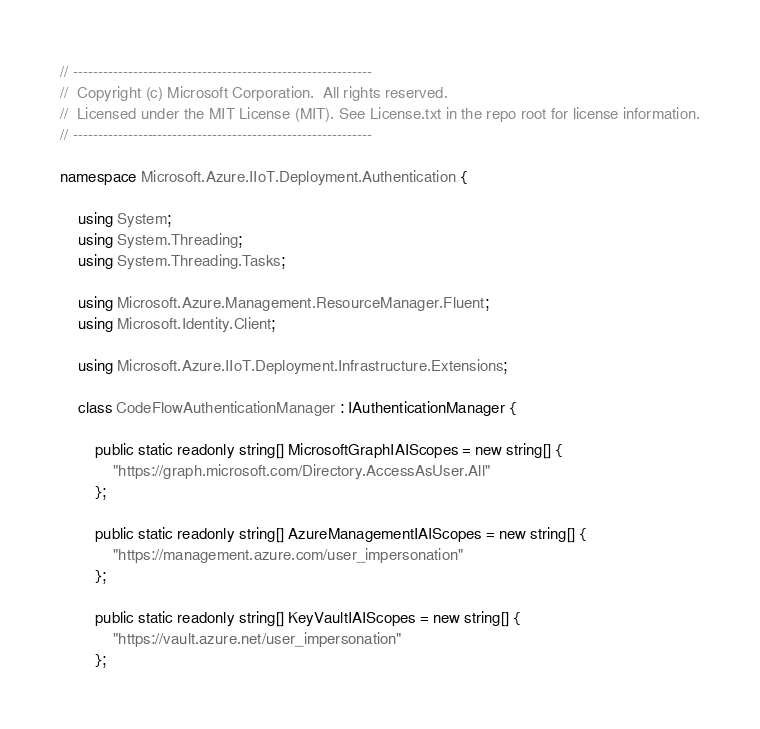Convert code to text. <code><loc_0><loc_0><loc_500><loc_500><_C#_>// ------------------------------------------------------------
//  Copyright (c) Microsoft Corporation.  All rights reserved.
//  Licensed under the MIT License (MIT). See License.txt in the repo root for license information.
// ------------------------------------------------------------

namespace Microsoft.Azure.IIoT.Deployment.Authentication {

    using System;
    using System.Threading;
    using System.Threading.Tasks;

    using Microsoft.Azure.Management.ResourceManager.Fluent;
    using Microsoft.Identity.Client;

    using Microsoft.Azure.IIoT.Deployment.Infrastructure.Extensions;

    class CodeFlowAuthenticationManager : IAuthenticationManager {

        public static readonly string[] MicrosoftGraphIAIScopes = new string[] {
            "https://graph.microsoft.com/Directory.AccessAsUser.All"
        };

        public static readonly string[] AzureManagementIAIScopes = new string[] {
            "https://management.azure.com/user_impersonation"
        };

        public static readonly string[] KeyVaultIAIScopes = new string[] {
            "https://vault.azure.net/user_impersonation"
        };

</code> 